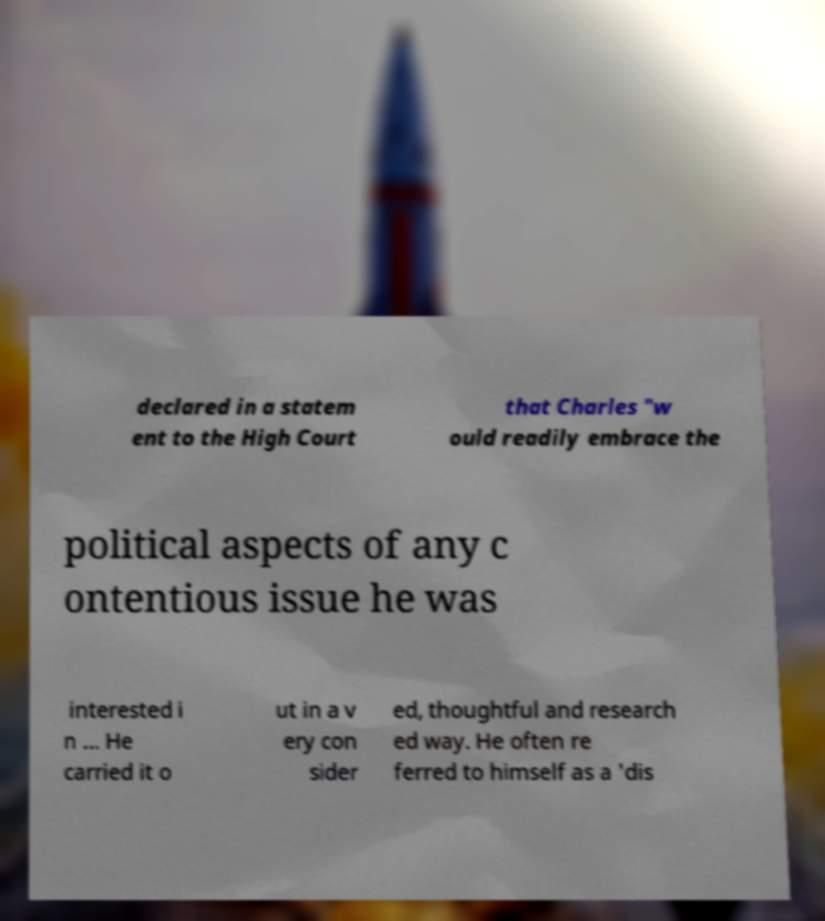There's text embedded in this image that I need extracted. Can you transcribe it verbatim? declared in a statem ent to the High Court that Charles "w ould readily embrace the political aspects of any c ontentious issue he was interested i n ... He carried it o ut in a v ery con sider ed, thoughtful and research ed way. He often re ferred to himself as a 'dis 